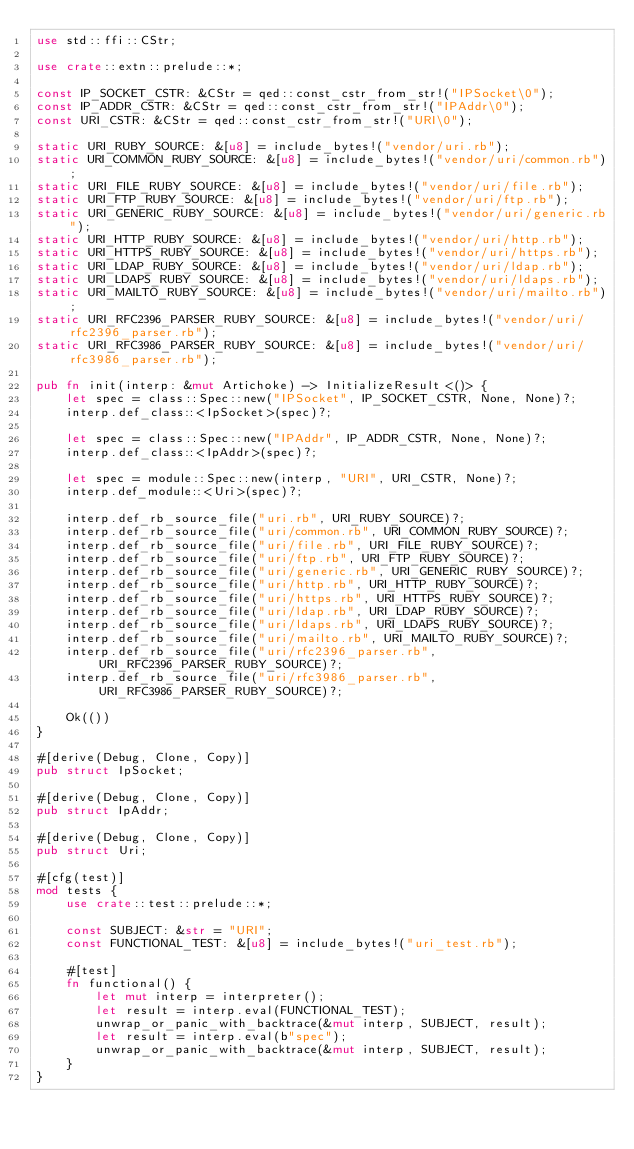<code> <loc_0><loc_0><loc_500><loc_500><_Rust_>use std::ffi::CStr;

use crate::extn::prelude::*;

const IP_SOCKET_CSTR: &CStr = qed::const_cstr_from_str!("IPSocket\0");
const IP_ADDR_CSTR: &CStr = qed::const_cstr_from_str!("IPAddr\0");
const URI_CSTR: &CStr = qed::const_cstr_from_str!("URI\0");

static URI_RUBY_SOURCE: &[u8] = include_bytes!("vendor/uri.rb");
static URI_COMMON_RUBY_SOURCE: &[u8] = include_bytes!("vendor/uri/common.rb");
static URI_FILE_RUBY_SOURCE: &[u8] = include_bytes!("vendor/uri/file.rb");
static URI_FTP_RUBY_SOURCE: &[u8] = include_bytes!("vendor/uri/ftp.rb");
static URI_GENERIC_RUBY_SOURCE: &[u8] = include_bytes!("vendor/uri/generic.rb");
static URI_HTTP_RUBY_SOURCE: &[u8] = include_bytes!("vendor/uri/http.rb");
static URI_HTTPS_RUBY_SOURCE: &[u8] = include_bytes!("vendor/uri/https.rb");
static URI_LDAP_RUBY_SOURCE: &[u8] = include_bytes!("vendor/uri/ldap.rb");
static URI_LDAPS_RUBY_SOURCE: &[u8] = include_bytes!("vendor/uri/ldaps.rb");
static URI_MAILTO_RUBY_SOURCE: &[u8] = include_bytes!("vendor/uri/mailto.rb");
static URI_RFC2396_PARSER_RUBY_SOURCE: &[u8] = include_bytes!("vendor/uri/rfc2396_parser.rb");
static URI_RFC3986_PARSER_RUBY_SOURCE: &[u8] = include_bytes!("vendor/uri/rfc3986_parser.rb");

pub fn init(interp: &mut Artichoke) -> InitializeResult<()> {
    let spec = class::Spec::new("IPSocket", IP_SOCKET_CSTR, None, None)?;
    interp.def_class::<IpSocket>(spec)?;

    let spec = class::Spec::new("IPAddr", IP_ADDR_CSTR, None, None)?;
    interp.def_class::<IpAddr>(spec)?;

    let spec = module::Spec::new(interp, "URI", URI_CSTR, None)?;
    interp.def_module::<Uri>(spec)?;

    interp.def_rb_source_file("uri.rb", URI_RUBY_SOURCE)?;
    interp.def_rb_source_file("uri/common.rb", URI_COMMON_RUBY_SOURCE)?;
    interp.def_rb_source_file("uri/file.rb", URI_FILE_RUBY_SOURCE)?;
    interp.def_rb_source_file("uri/ftp.rb", URI_FTP_RUBY_SOURCE)?;
    interp.def_rb_source_file("uri/generic.rb", URI_GENERIC_RUBY_SOURCE)?;
    interp.def_rb_source_file("uri/http.rb", URI_HTTP_RUBY_SOURCE)?;
    interp.def_rb_source_file("uri/https.rb", URI_HTTPS_RUBY_SOURCE)?;
    interp.def_rb_source_file("uri/ldap.rb", URI_LDAP_RUBY_SOURCE)?;
    interp.def_rb_source_file("uri/ldaps.rb", URI_LDAPS_RUBY_SOURCE)?;
    interp.def_rb_source_file("uri/mailto.rb", URI_MAILTO_RUBY_SOURCE)?;
    interp.def_rb_source_file("uri/rfc2396_parser.rb", URI_RFC2396_PARSER_RUBY_SOURCE)?;
    interp.def_rb_source_file("uri/rfc3986_parser.rb", URI_RFC3986_PARSER_RUBY_SOURCE)?;

    Ok(())
}

#[derive(Debug, Clone, Copy)]
pub struct IpSocket;

#[derive(Debug, Clone, Copy)]
pub struct IpAddr;

#[derive(Debug, Clone, Copy)]
pub struct Uri;

#[cfg(test)]
mod tests {
    use crate::test::prelude::*;

    const SUBJECT: &str = "URI";
    const FUNCTIONAL_TEST: &[u8] = include_bytes!("uri_test.rb");

    #[test]
    fn functional() {
        let mut interp = interpreter();
        let result = interp.eval(FUNCTIONAL_TEST);
        unwrap_or_panic_with_backtrace(&mut interp, SUBJECT, result);
        let result = interp.eval(b"spec");
        unwrap_or_panic_with_backtrace(&mut interp, SUBJECT, result);
    }
}
</code> 